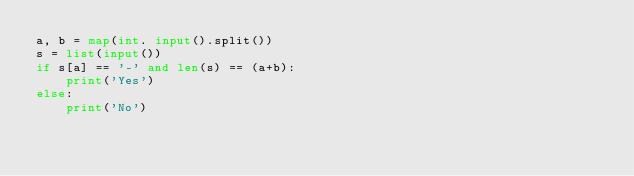Convert code to text. <code><loc_0><loc_0><loc_500><loc_500><_Python_>a, b = map(int. input().split())
s = list(input())
if s[a] == '-' and len(s) == (a+b):
    print('Yes')
else:
    print('No')</code> 